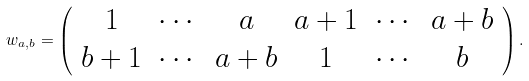<formula> <loc_0><loc_0><loc_500><loc_500>w _ { a , b } = \left ( \begin{array} { * 6 c } 1 & \cdots & a & a + 1 & \cdots & a + b \\ b + 1 & \cdots & a + b & 1 & \cdots & b \end{array} \right ) .</formula> 